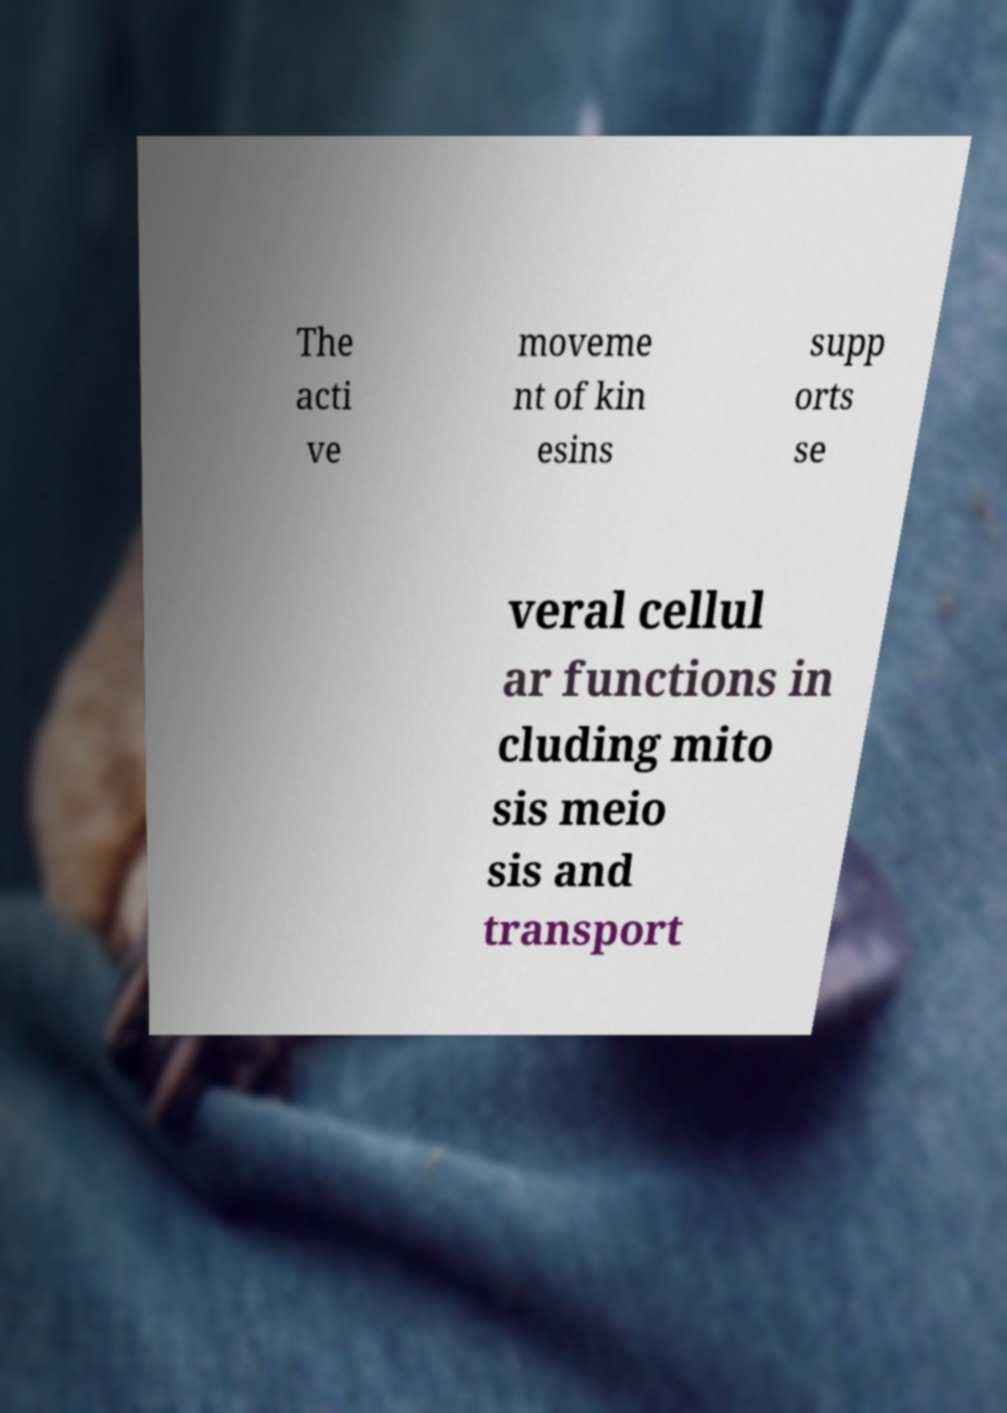For documentation purposes, I need the text within this image transcribed. Could you provide that? The acti ve moveme nt of kin esins supp orts se veral cellul ar functions in cluding mito sis meio sis and transport 